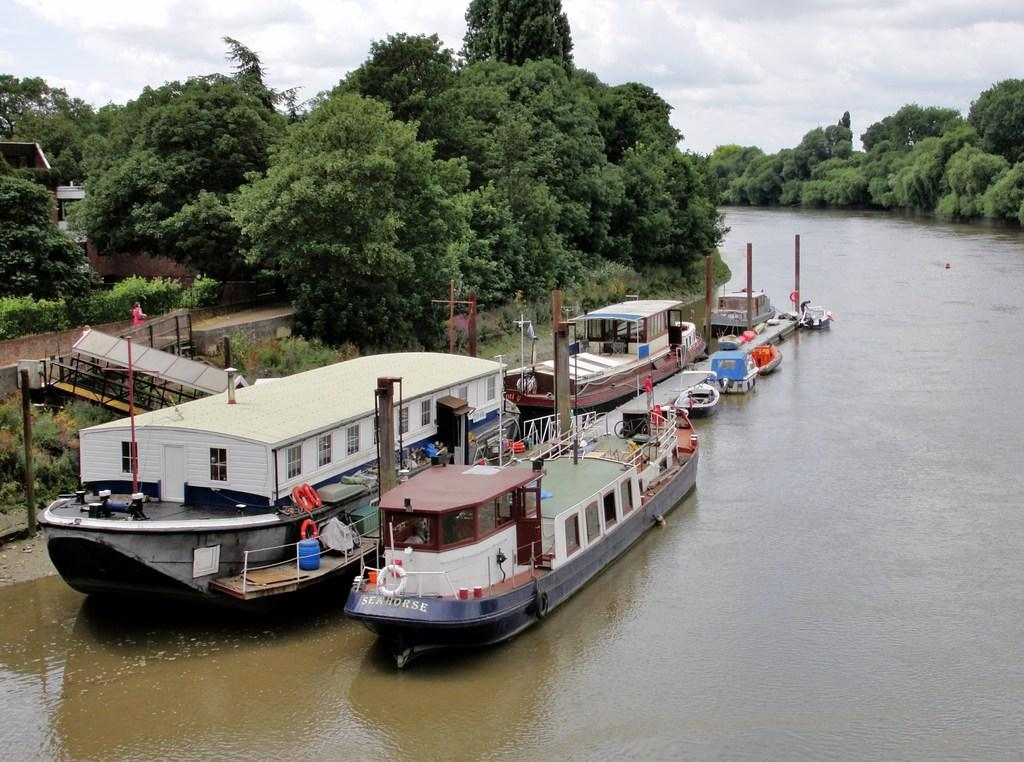What is on the water in the image? There are boats on the water in the image. What can be seen in the background of the image? There are trees and a house visible in the background of the image. What type of brick is used to build the house in the image? There is no mention of brick in the image, as it only shows boats on the water and trees and a house in the background. 